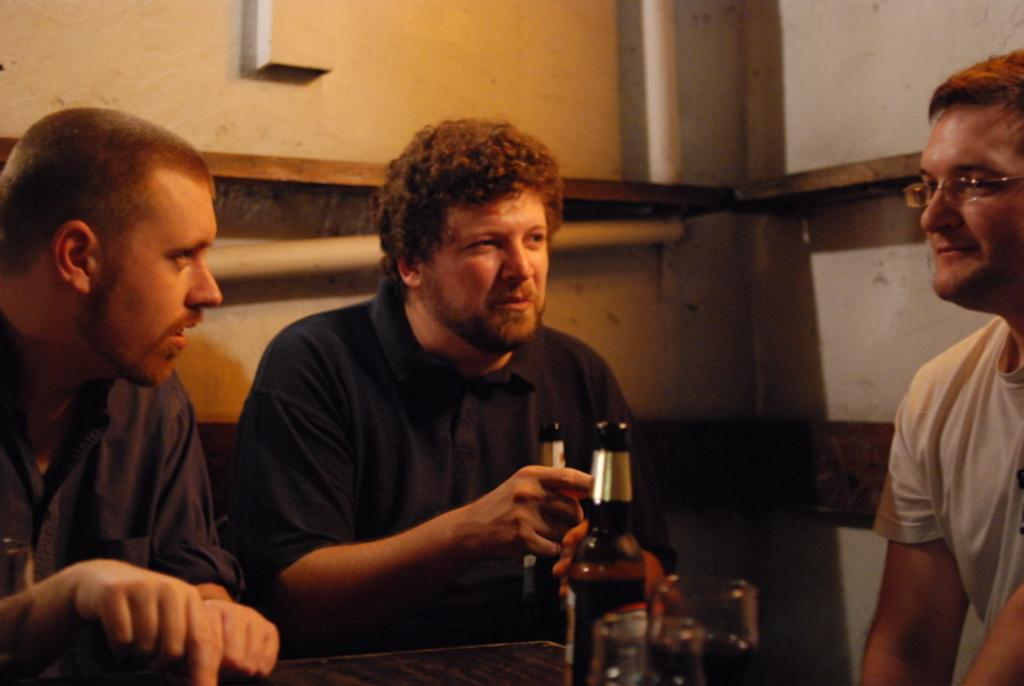How many people are seated in the image? There are three men seated in the image. What can be seen on the table in front of the men? There are bottles and glasses on the table. What is one of the men holding in his hand? One man is holding a beer bottle in his hand. Can you describe the appearance of one of the men? One man is wearing spectacles in the image. What type of church is visible in the background of the image? There is no church visible in the background of the image. Can you tell me how many mittens are on the table in the image? There are no mittens present in the image. 